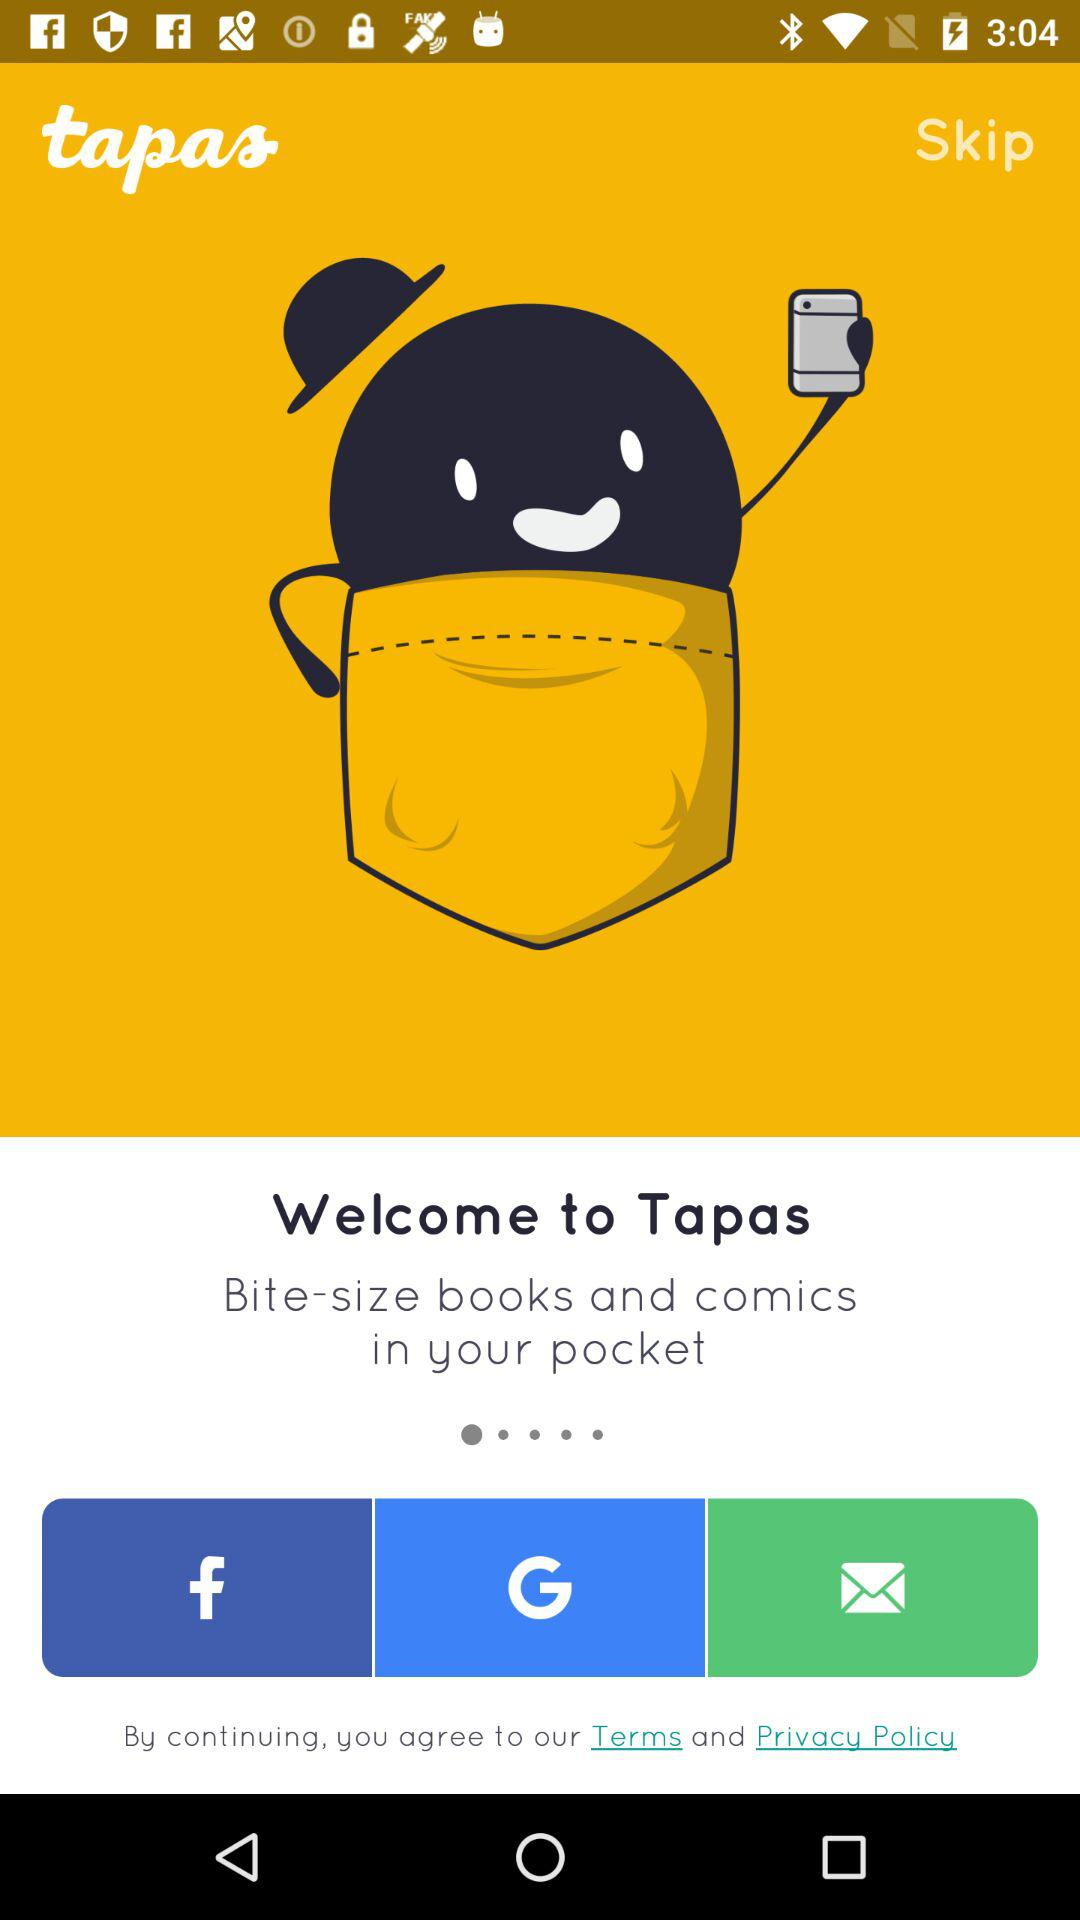What is the name of the application? The name of the application is "tapas". 